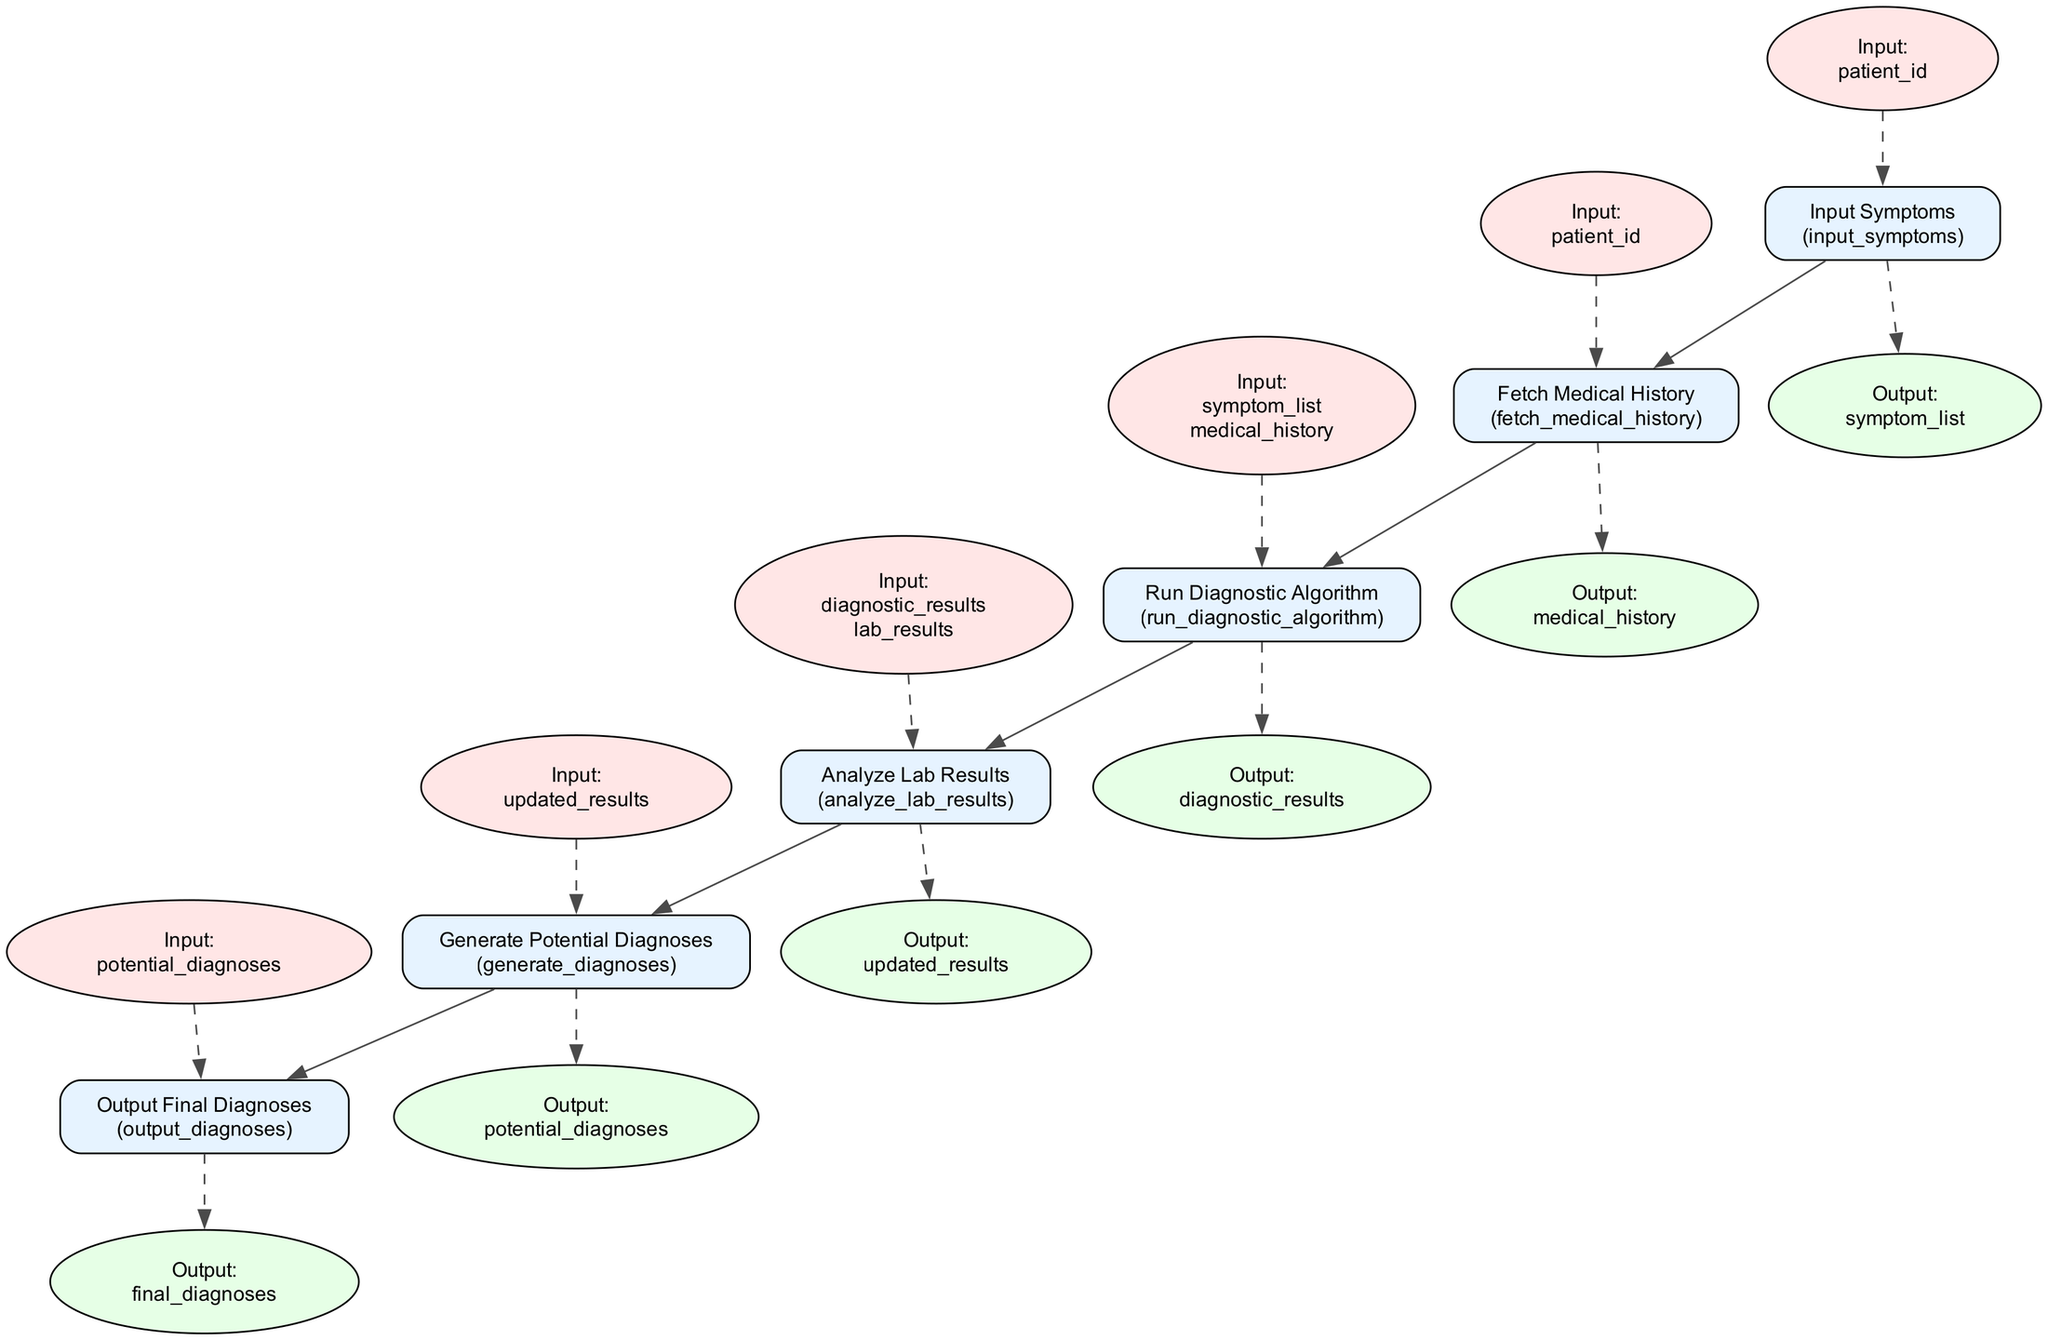What is the first step in the flowchart? The flowchart begins with the step "Input Symptoms," as it is the first node listed in the diagram.
Answer: Input Symptoms How many steps are there in total? By counting the number of nodes in the diagram, there are six steps present, from inputting symptoms to outputting final diagnoses.
Answer: 6 What is the output of the "Run Diagnostic Algorithm"? The output of the "Run Diagnostic Algorithm" step is "diagnostic_results," which is indicated as the output for this function in the diagram.
Answer: diagnostic_results Which function retrieves the patient's medical history? The function responsible for retrieving the patient's medical history is called "fetch_medical_history," as labeled in the corresponding node.
Answer: fetch_medical_history What provides inputs for the "Analyze Lab Results" step? "diagnostic_results" and "lab_results" serve as inputs for the "Analyze Lab Results" step, as shown in the diagram with a dashed edge leading to this node.
Answer: diagnostic_results and lab_results What is the final step of the process? The final step in the flowchart is "Output Final Diagnoses," which represents the concluding process of the diagnostic procedure.
Answer: Output Final Diagnoses How does the flowchart connect "Generate Potential Diagnoses" and "Output Final Diagnoses"? The "Generate Potential Diagnoses" step directly connects to the "Output Final Diagnoses" step, indicating that the output of the former serves as input to the latter.
Answer: Direct connection What is the purpose of incorporating lab results in the diagnostic process? Incorporating lab results aims to achieve more accurate diagnoses, as stated in the description of the "Analyze Lab Results" step in the diagram.
Answer: More accurate diagnosis 